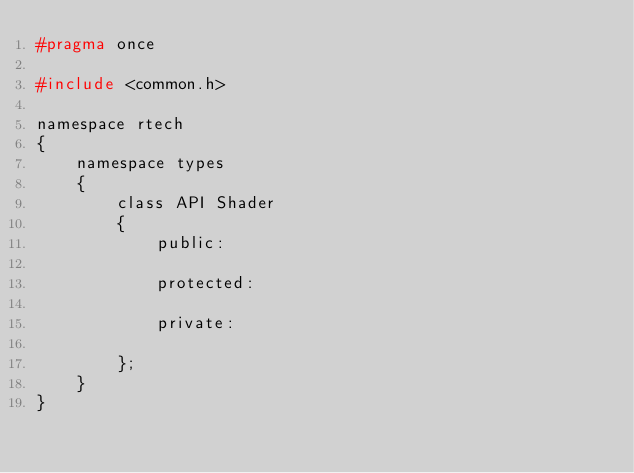<code> <loc_0><loc_0><loc_500><loc_500><_C_>#pragma once

#include <common.h>

namespace rtech
{
    namespace types
    {
        class API Shader
        {
            public:

            protected:

            private:

        };
    }
}</code> 